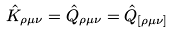<formula> <loc_0><loc_0><loc_500><loc_500>\hat { K } _ { \rho \mu \nu } = \hat { Q } _ { \rho \mu \nu } = \hat { Q } _ { [ \rho \mu \nu ] }</formula> 